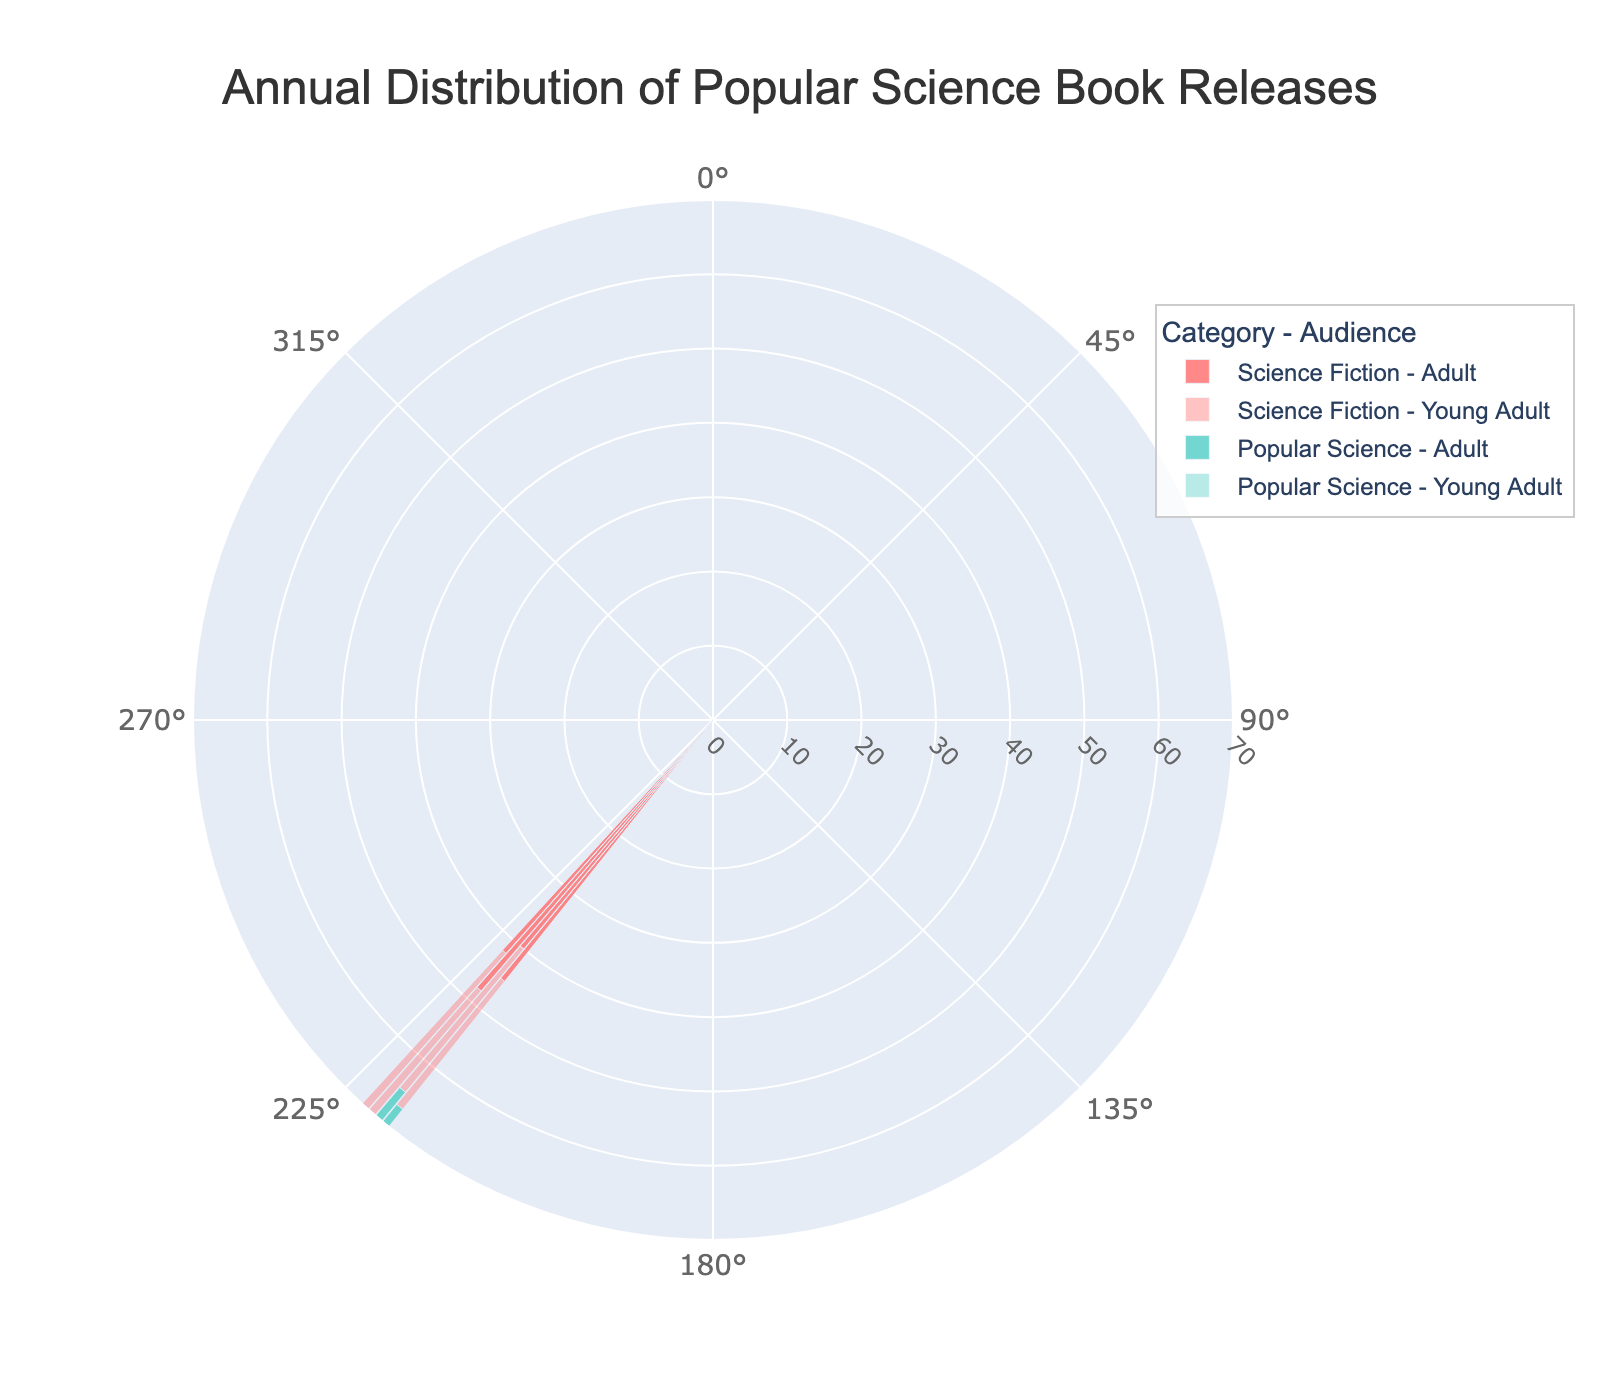what is the title of the plot? The title of the plot is displayed at the top of the figure. It provides the main subject of the visualization, helping viewers understand the context at a glance.
Answer: Annual Distribution of Popular Science Book Releases what are the named categories in the plot? The categories represent the different genres of books included in the analysis. They are usually displayed in the legend or in the figure labels.
Answer: Science Fiction, Popular Science how many demographics are included in the dataset, and what are they? The demographics represent the different audience groups targeted by the book releases. These groups are generally shown in the legend alongside the categories.
Answer: Two demographics: Young Adult, Adult in which year did the adult audience have the highest number of popular science book releases? To find this, look at the segments for Popular Science - Adult and identify the year with the highest radius value on the rose chart.
Answer: 2022 what is the range of values on the radial axis? The radial axis values are shown as tick marks around the circles, indicating the extent of book releases for each demographic across different years.
Answer: 0 to 70 how many book releases were there for young adults in science fiction genre in 2021? Locate the segment labeled Science Fiction - Young Adult for the year 2021 and read the radial value.
Answer: 30 what is the difference in the number of adult book releases between popular science and science fiction in 2020? Find the radial values for Adult in 2020 for both Science Fiction and Popular Science categories, then calculate the difference (Popular Science - Science Fiction).
Answer: 15 (55 - 40) how has the number of adult science fiction book releases changed from 2019 to 2022? Observe the radial segments of Science Fiction - Adult for the years 2019 and 2022 and compare their sizes to describe the change.
Answer: Decreased from 45 to 42 which category and demographic had the lowest number of book releases in 2019? Compare all the segments for the year 2019 and find the lowest radial value.
Answer: Popular Science - Young Adult are there any patterns in the distribution of book releases for young adults over the years? Analyze the rose chart sectors representing the Young Adult demographic across all years and both categories to identify any consistent trends or variances.
Answer: Slight increasing trend overall 